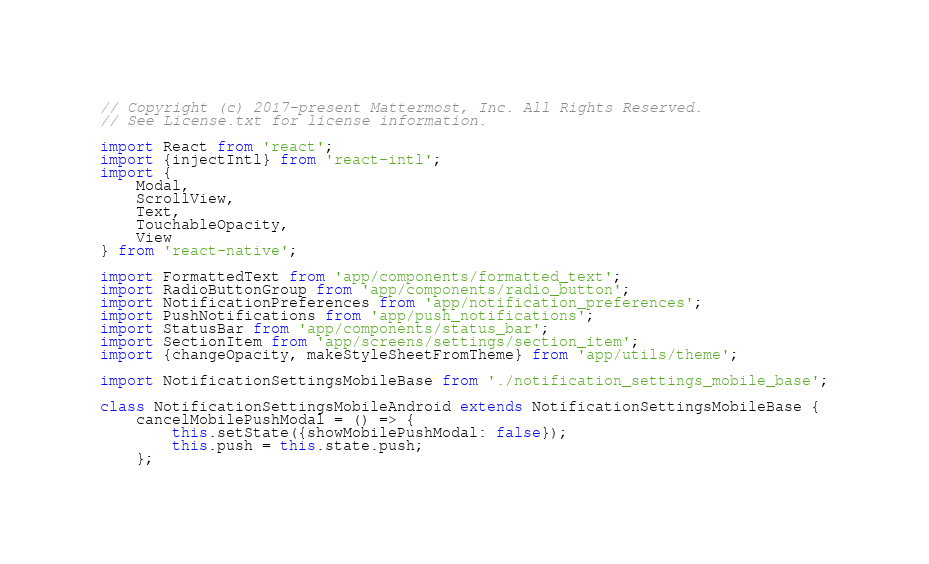Convert code to text. <code><loc_0><loc_0><loc_500><loc_500><_JavaScript_>// Copyright (c) 2017-present Mattermost, Inc. All Rights Reserved.
// See License.txt for license information.

import React from 'react';
import {injectIntl} from 'react-intl';
import {
    Modal,
    ScrollView,
    Text,
    TouchableOpacity,
    View
} from 'react-native';

import FormattedText from 'app/components/formatted_text';
import RadioButtonGroup from 'app/components/radio_button';
import NotificationPreferences from 'app/notification_preferences';
import PushNotifications from 'app/push_notifications';
import StatusBar from 'app/components/status_bar';
import SectionItem from 'app/screens/settings/section_item';
import {changeOpacity, makeStyleSheetFromTheme} from 'app/utils/theme';

import NotificationSettingsMobileBase from './notification_settings_mobile_base';

class NotificationSettingsMobileAndroid extends NotificationSettingsMobileBase {
    cancelMobilePushModal = () => {
        this.setState({showMobilePushModal: false});
        this.push = this.state.push;
    };
</code> 